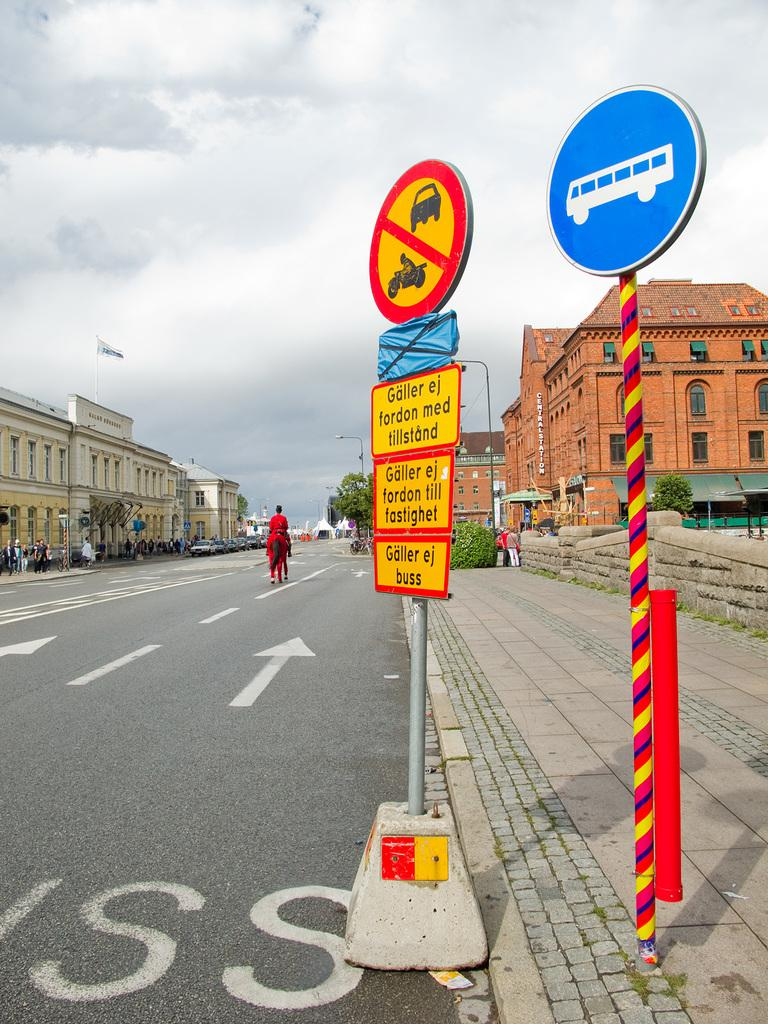<image>
Relay a brief, clear account of the picture shown. A sign at the bottom of a group of signs reads "Galler ej buss". 